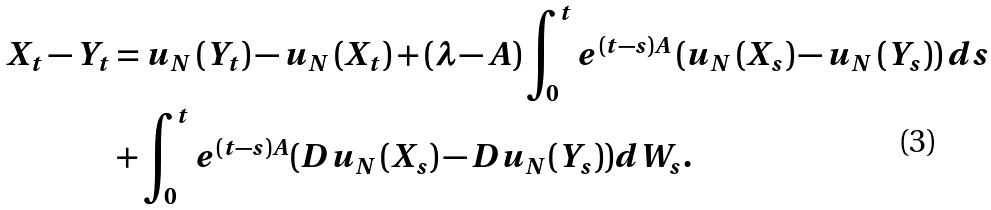<formula> <loc_0><loc_0><loc_500><loc_500>X _ { t } - Y _ { t } & = u _ { N } \left ( Y _ { t } \right ) - u _ { N } \left ( X _ { t } \right ) + \left ( \lambda - A \right ) \int _ { 0 } ^ { t } e ^ { \left ( t - s \right ) A } \left ( u _ { N } \left ( X _ { s } \right ) - u _ { N } \left ( Y _ { s } \right ) \right ) d s \\ & + \int _ { 0 } ^ { t } e ^ { \left ( t - s \right ) A } ( D u _ { N } \left ( X _ { s } \right ) - D u _ { N } ( Y _ { s } ) ) d W _ { s } .</formula> 